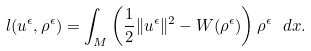Convert formula to latex. <formula><loc_0><loc_0><loc_500><loc_500>l ( u ^ { \epsilon } , \rho ^ { \epsilon } ) = \int _ { M } \left ( \frac { 1 } { 2 } \| u ^ { \epsilon } \| ^ { 2 } - W ( \rho ^ { \epsilon } ) \right ) \rho ^ { \epsilon } \ d x .</formula> 